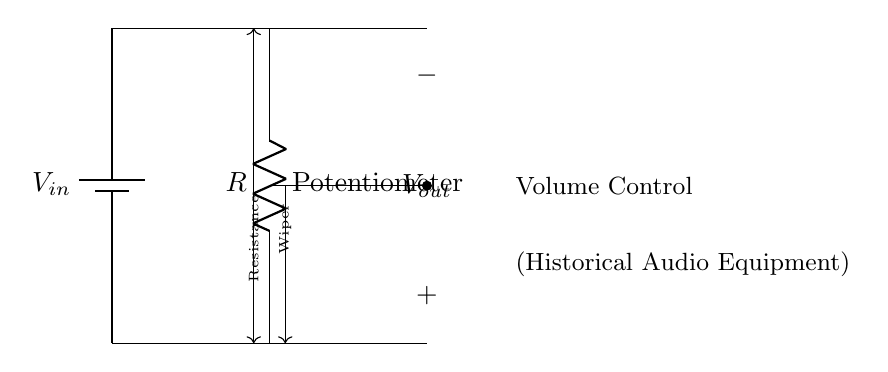What is the input voltage in this circuit? The input voltage is represented as V_in, indicating the applied voltage at the top of the potentiometer.
Answer: V_in What component is used for volume control? The component used for volume control is a potentiometer, as labeled in the circuit diagram.
Answer: Potentiometer What does V_out represent in this circuit? V_out represents the output voltage taken from the wiper of the potentiometer to control the volume level.
Answer: V_out How many terminals does the potentiometer have in this circuit? The potentiometer in this circuit has three terminals: one connected to the input voltage, one to ground, and one (the wiper) for output voltage.
Answer: Three What happens to the output voltage as the wiper moves up? As the wiper moves up, the resistance to ground decreases, thus increasing the output voltage.
Answer: Increases What is the purpose of the resistor labeled R in this circuit? The resistor labeled R represents the variable resistance of the potentiometer that changes the division of voltage across it to control output.
Answer: Variable resistance What effect does changing the position of the wiper have on the circuit? Changing the position of the wiper alters the ratio of resistances, thereby adjusting the output voltage V_out according to the desired volume level.
Answer: Adjusts output voltage 